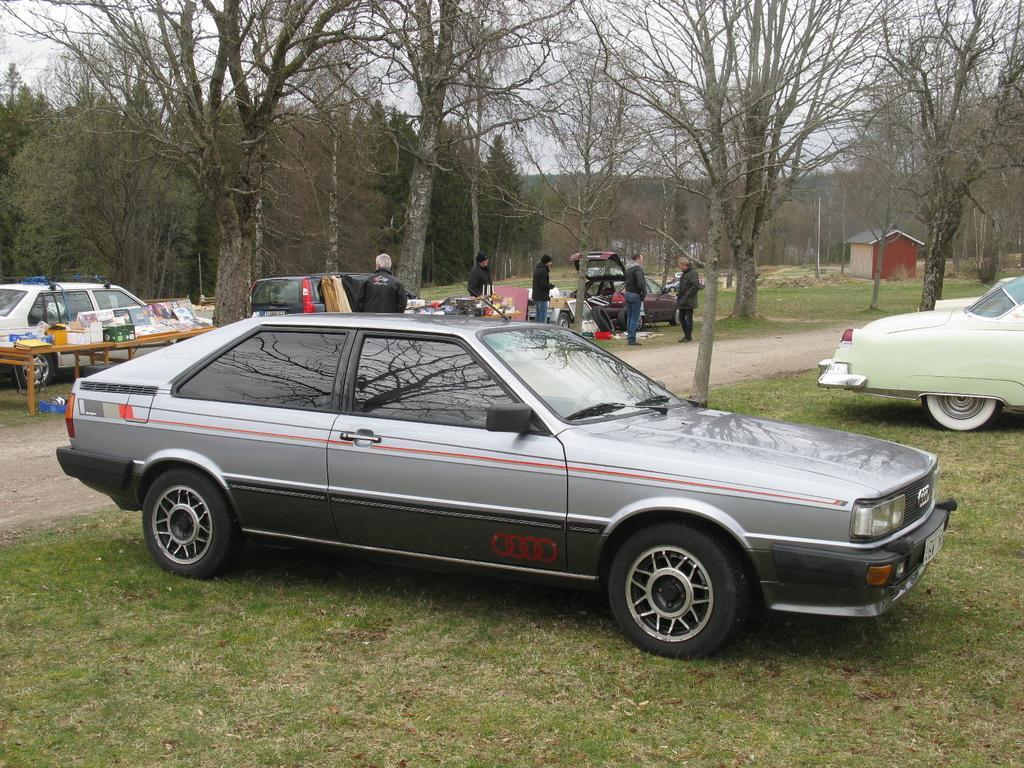Please provide a concise description of this image. In this image there are few people, vehicles, few objects on the tables, a booth, grass, trees and the sky. 